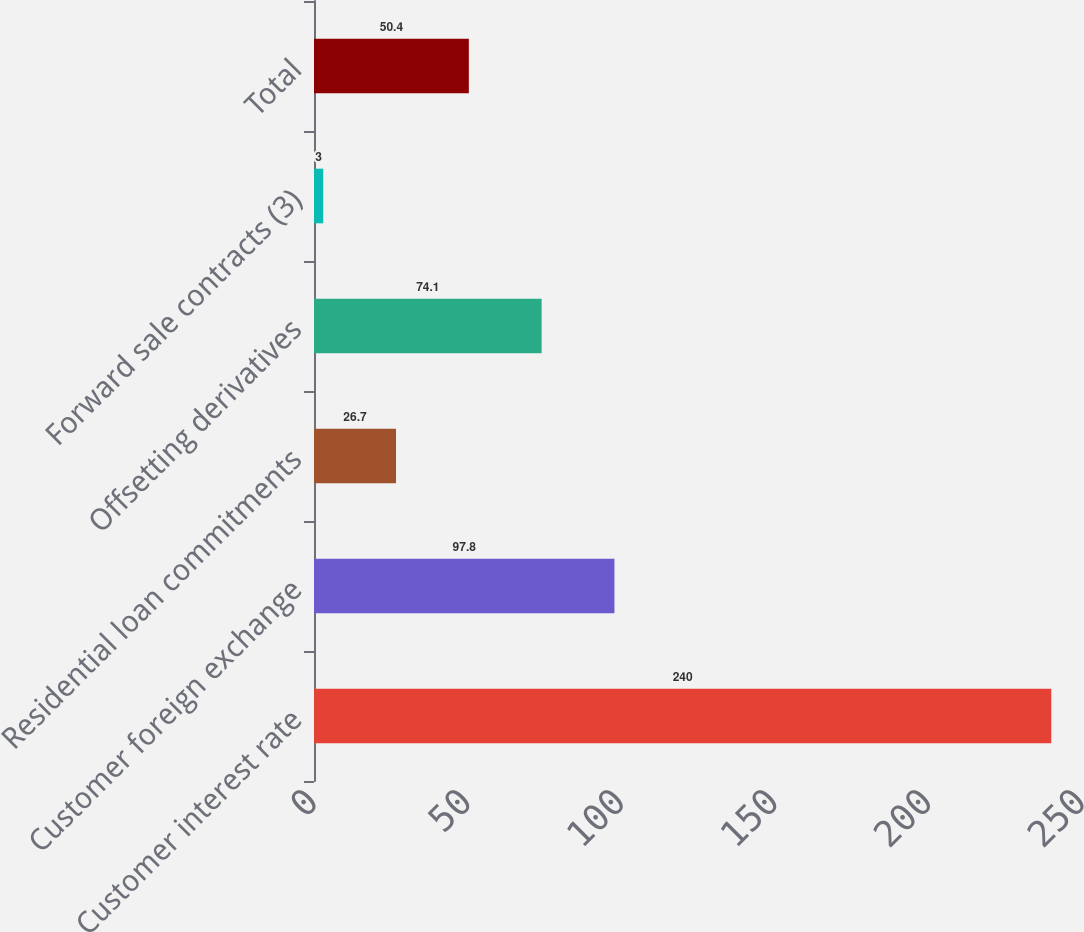Convert chart. <chart><loc_0><loc_0><loc_500><loc_500><bar_chart><fcel>Customer interest rate<fcel>Customer foreign exchange<fcel>Residential loan commitments<fcel>Offsetting derivatives<fcel>Forward sale contracts (3)<fcel>Total<nl><fcel>240<fcel>97.8<fcel>26.7<fcel>74.1<fcel>3<fcel>50.4<nl></chart> 